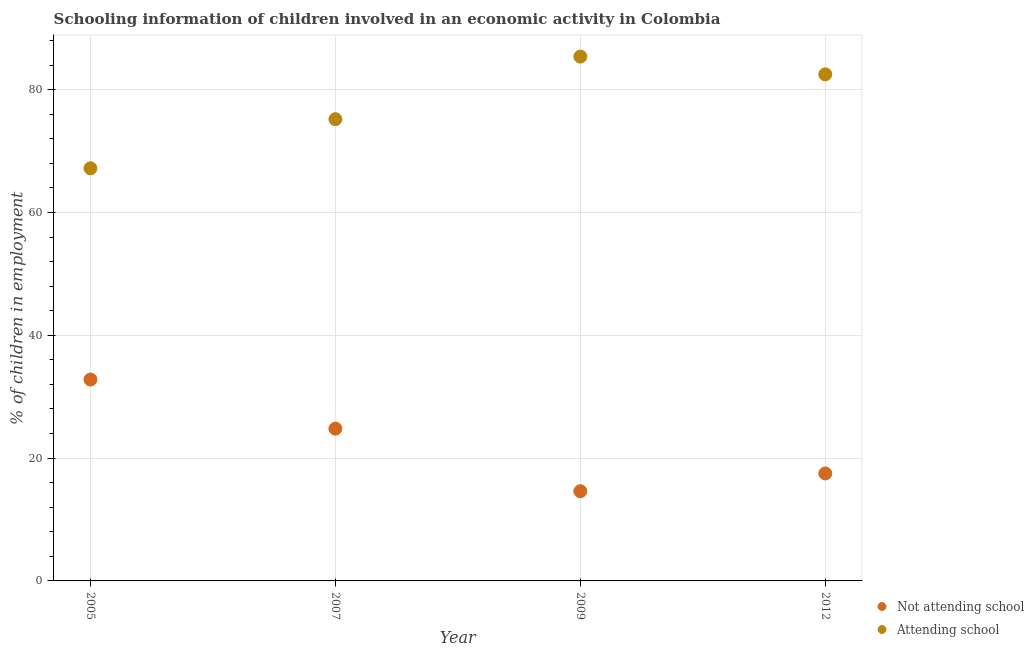Is the number of dotlines equal to the number of legend labels?
Offer a very short reply. Yes. What is the percentage of employed children who are attending school in 2005?
Give a very brief answer. 67.2. Across all years, what is the maximum percentage of employed children who are attending school?
Offer a very short reply. 85.39. Across all years, what is the minimum percentage of employed children who are attending school?
Ensure brevity in your answer.  67.2. In which year was the percentage of employed children who are not attending school maximum?
Your answer should be very brief. 2005. In which year was the percentage of employed children who are attending school minimum?
Ensure brevity in your answer.  2005. What is the total percentage of employed children who are not attending school in the graph?
Ensure brevity in your answer.  89.71. What is the difference between the percentage of employed children who are attending school in 2007 and that in 2012?
Your answer should be very brief. -7.3. What is the difference between the percentage of employed children who are attending school in 2007 and the percentage of employed children who are not attending school in 2005?
Make the answer very short. 42.4. What is the average percentage of employed children who are not attending school per year?
Your answer should be very brief. 22.43. In the year 2005, what is the difference between the percentage of employed children who are attending school and percentage of employed children who are not attending school?
Your response must be concise. 34.4. In how many years, is the percentage of employed children who are not attending school greater than 72 %?
Keep it short and to the point. 0. What is the ratio of the percentage of employed children who are attending school in 2009 to that in 2012?
Your answer should be very brief. 1.04. Is the difference between the percentage of employed children who are not attending school in 2005 and 2007 greater than the difference between the percentage of employed children who are attending school in 2005 and 2007?
Offer a very short reply. Yes. What is the difference between the highest and the second highest percentage of employed children who are attending school?
Your answer should be very brief. 2.89. What is the difference between the highest and the lowest percentage of employed children who are attending school?
Your answer should be compact. 18.19. In how many years, is the percentage of employed children who are not attending school greater than the average percentage of employed children who are not attending school taken over all years?
Give a very brief answer. 2. Does the percentage of employed children who are not attending school monotonically increase over the years?
Ensure brevity in your answer.  No. Is the percentage of employed children who are attending school strictly greater than the percentage of employed children who are not attending school over the years?
Ensure brevity in your answer.  Yes. What is the title of the graph?
Your response must be concise. Schooling information of children involved in an economic activity in Colombia. Does "From human activities" appear as one of the legend labels in the graph?
Provide a succinct answer. No. What is the label or title of the Y-axis?
Offer a very short reply. % of children in employment. What is the % of children in employment in Not attending school in 2005?
Provide a succinct answer. 32.8. What is the % of children in employment in Attending school in 2005?
Your answer should be compact. 67.2. What is the % of children in employment in Not attending school in 2007?
Your answer should be very brief. 24.8. What is the % of children in employment of Attending school in 2007?
Your response must be concise. 75.2. What is the % of children in employment of Not attending school in 2009?
Offer a terse response. 14.61. What is the % of children in employment in Attending school in 2009?
Provide a succinct answer. 85.39. What is the % of children in employment of Not attending school in 2012?
Offer a very short reply. 17.5. What is the % of children in employment in Attending school in 2012?
Provide a short and direct response. 82.5. Across all years, what is the maximum % of children in employment in Not attending school?
Make the answer very short. 32.8. Across all years, what is the maximum % of children in employment in Attending school?
Your answer should be very brief. 85.39. Across all years, what is the minimum % of children in employment in Not attending school?
Give a very brief answer. 14.61. Across all years, what is the minimum % of children in employment of Attending school?
Your response must be concise. 67.2. What is the total % of children in employment of Not attending school in the graph?
Your answer should be very brief. 89.71. What is the total % of children in employment of Attending school in the graph?
Make the answer very short. 310.29. What is the difference between the % of children in employment of Not attending school in 2005 and that in 2007?
Ensure brevity in your answer.  8. What is the difference between the % of children in employment of Not attending school in 2005 and that in 2009?
Provide a succinct answer. 18.19. What is the difference between the % of children in employment in Attending school in 2005 and that in 2009?
Your answer should be very brief. -18.19. What is the difference between the % of children in employment of Attending school in 2005 and that in 2012?
Your response must be concise. -15.3. What is the difference between the % of children in employment in Not attending school in 2007 and that in 2009?
Provide a short and direct response. 10.19. What is the difference between the % of children in employment in Attending school in 2007 and that in 2009?
Keep it short and to the point. -10.19. What is the difference between the % of children in employment of Attending school in 2007 and that in 2012?
Offer a terse response. -7.3. What is the difference between the % of children in employment of Not attending school in 2009 and that in 2012?
Offer a terse response. -2.89. What is the difference between the % of children in employment in Attending school in 2009 and that in 2012?
Keep it short and to the point. 2.89. What is the difference between the % of children in employment of Not attending school in 2005 and the % of children in employment of Attending school in 2007?
Provide a succinct answer. -42.4. What is the difference between the % of children in employment in Not attending school in 2005 and the % of children in employment in Attending school in 2009?
Provide a short and direct response. -52.59. What is the difference between the % of children in employment of Not attending school in 2005 and the % of children in employment of Attending school in 2012?
Offer a very short reply. -49.7. What is the difference between the % of children in employment of Not attending school in 2007 and the % of children in employment of Attending school in 2009?
Ensure brevity in your answer.  -60.59. What is the difference between the % of children in employment of Not attending school in 2007 and the % of children in employment of Attending school in 2012?
Keep it short and to the point. -57.7. What is the difference between the % of children in employment in Not attending school in 2009 and the % of children in employment in Attending school in 2012?
Keep it short and to the point. -67.89. What is the average % of children in employment of Not attending school per year?
Provide a short and direct response. 22.43. What is the average % of children in employment in Attending school per year?
Give a very brief answer. 77.57. In the year 2005, what is the difference between the % of children in employment of Not attending school and % of children in employment of Attending school?
Offer a terse response. -34.4. In the year 2007, what is the difference between the % of children in employment in Not attending school and % of children in employment in Attending school?
Provide a short and direct response. -50.4. In the year 2009, what is the difference between the % of children in employment of Not attending school and % of children in employment of Attending school?
Provide a short and direct response. -70.78. In the year 2012, what is the difference between the % of children in employment in Not attending school and % of children in employment in Attending school?
Ensure brevity in your answer.  -65. What is the ratio of the % of children in employment of Not attending school in 2005 to that in 2007?
Your response must be concise. 1.32. What is the ratio of the % of children in employment in Attending school in 2005 to that in 2007?
Offer a very short reply. 0.89. What is the ratio of the % of children in employment of Not attending school in 2005 to that in 2009?
Your response must be concise. 2.25. What is the ratio of the % of children in employment of Attending school in 2005 to that in 2009?
Offer a terse response. 0.79. What is the ratio of the % of children in employment in Not attending school in 2005 to that in 2012?
Your response must be concise. 1.87. What is the ratio of the % of children in employment of Attending school in 2005 to that in 2012?
Provide a short and direct response. 0.81. What is the ratio of the % of children in employment in Not attending school in 2007 to that in 2009?
Offer a terse response. 1.7. What is the ratio of the % of children in employment of Attending school in 2007 to that in 2009?
Your response must be concise. 0.88. What is the ratio of the % of children in employment in Not attending school in 2007 to that in 2012?
Your answer should be very brief. 1.42. What is the ratio of the % of children in employment of Attending school in 2007 to that in 2012?
Offer a terse response. 0.91. What is the ratio of the % of children in employment of Not attending school in 2009 to that in 2012?
Ensure brevity in your answer.  0.83. What is the ratio of the % of children in employment in Attending school in 2009 to that in 2012?
Keep it short and to the point. 1.03. What is the difference between the highest and the second highest % of children in employment of Attending school?
Provide a succinct answer. 2.89. What is the difference between the highest and the lowest % of children in employment of Not attending school?
Your response must be concise. 18.19. What is the difference between the highest and the lowest % of children in employment in Attending school?
Your response must be concise. 18.19. 